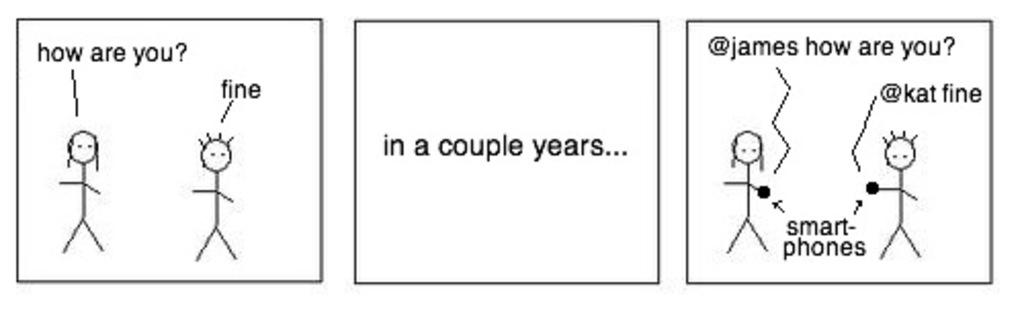What is depicted in the image? There is a sketch of persons in the image. What else can be found in the image besides the sketch? There is something written in the image. What type of brick is used to build the stage in the image? There is no stage or brick present in the image; it only contains a sketch of persons and some written text. 